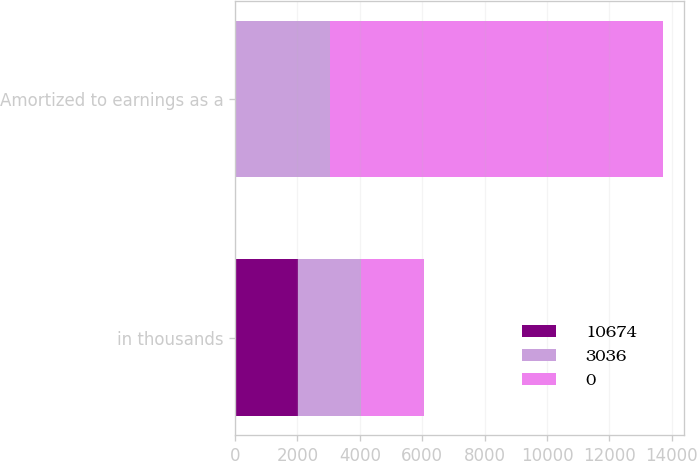<chart> <loc_0><loc_0><loc_500><loc_500><stacked_bar_chart><ecel><fcel>in thousands<fcel>Amortized to earnings as a<nl><fcel>10674<fcel>2016<fcel>0<nl><fcel>3036<fcel>2015<fcel>3036<nl><fcel>0<fcel>2014<fcel>10674<nl></chart> 